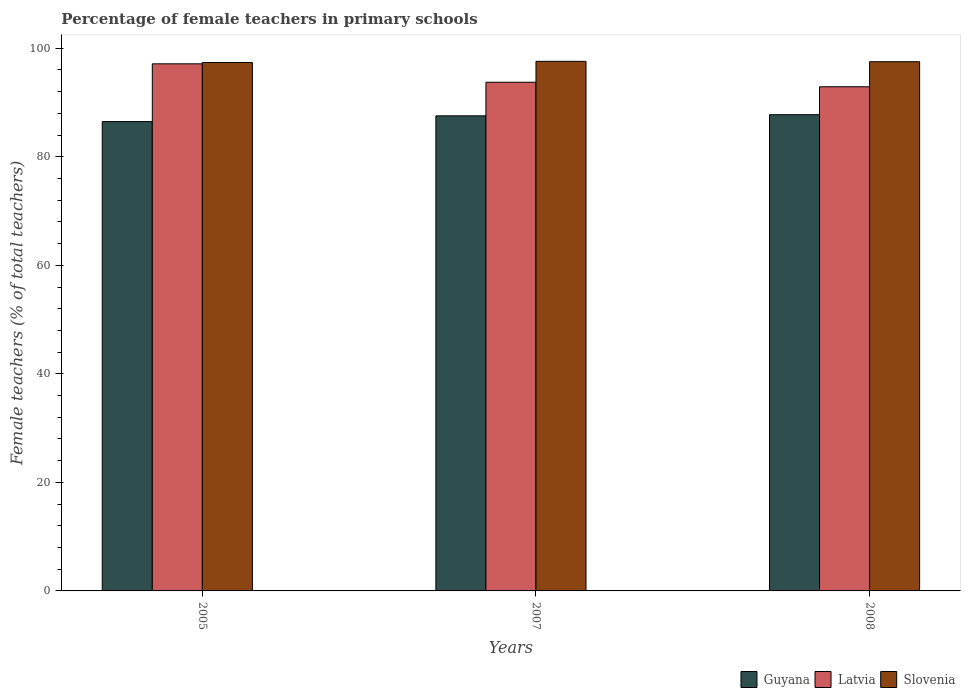How many different coloured bars are there?
Your response must be concise. 3. How many groups of bars are there?
Ensure brevity in your answer.  3. How many bars are there on the 1st tick from the left?
Make the answer very short. 3. How many bars are there on the 3rd tick from the right?
Your response must be concise. 3. What is the percentage of female teachers in Latvia in 2008?
Offer a terse response. 92.89. Across all years, what is the maximum percentage of female teachers in Slovenia?
Your answer should be compact. 97.58. Across all years, what is the minimum percentage of female teachers in Guyana?
Your answer should be compact. 86.48. In which year was the percentage of female teachers in Slovenia minimum?
Give a very brief answer. 2005. What is the total percentage of female teachers in Slovenia in the graph?
Your response must be concise. 292.46. What is the difference between the percentage of female teachers in Latvia in 2007 and that in 2008?
Make the answer very short. 0.84. What is the difference between the percentage of female teachers in Slovenia in 2008 and the percentage of female teachers in Latvia in 2005?
Provide a short and direct response. 0.39. What is the average percentage of female teachers in Guyana per year?
Ensure brevity in your answer.  87.26. In the year 2008, what is the difference between the percentage of female teachers in Latvia and percentage of female teachers in Slovenia?
Ensure brevity in your answer.  -4.62. In how many years, is the percentage of female teachers in Slovenia greater than 96 %?
Your answer should be compact. 3. What is the ratio of the percentage of female teachers in Slovenia in 2007 to that in 2008?
Keep it short and to the point. 1. Is the percentage of female teachers in Guyana in 2005 less than that in 2007?
Your answer should be very brief. Yes. What is the difference between the highest and the second highest percentage of female teachers in Latvia?
Give a very brief answer. 3.39. What is the difference between the highest and the lowest percentage of female teachers in Guyana?
Your answer should be very brief. 1.27. What does the 1st bar from the left in 2007 represents?
Provide a short and direct response. Guyana. What does the 2nd bar from the right in 2007 represents?
Provide a short and direct response. Latvia. Is it the case that in every year, the sum of the percentage of female teachers in Slovenia and percentage of female teachers in Guyana is greater than the percentage of female teachers in Latvia?
Offer a terse response. Yes. How many bars are there?
Your response must be concise. 9. Are all the bars in the graph horizontal?
Give a very brief answer. No. What is the difference between two consecutive major ticks on the Y-axis?
Keep it short and to the point. 20. What is the title of the graph?
Provide a short and direct response. Percentage of female teachers in primary schools. What is the label or title of the Y-axis?
Give a very brief answer. Female teachers (% of total teachers). What is the Female teachers (% of total teachers) of Guyana in 2005?
Make the answer very short. 86.48. What is the Female teachers (% of total teachers) in Latvia in 2005?
Offer a very short reply. 97.12. What is the Female teachers (% of total teachers) of Slovenia in 2005?
Your answer should be very brief. 97.37. What is the Female teachers (% of total teachers) in Guyana in 2007?
Keep it short and to the point. 87.54. What is the Female teachers (% of total teachers) in Latvia in 2007?
Your answer should be compact. 93.73. What is the Female teachers (% of total teachers) in Slovenia in 2007?
Offer a terse response. 97.58. What is the Female teachers (% of total teachers) in Guyana in 2008?
Give a very brief answer. 87.75. What is the Female teachers (% of total teachers) of Latvia in 2008?
Make the answer very short. 92.89. What is the Female teachers (% of total teachers) of Slovenia in 2008?
Provide a short and direct response. 97.51. Across all years, what is the maximum Female teachers (% of total teachers) in Guyana?
Give a very brief answer. 87.75. Across all years, what is the maximum Female teachers (% of total teachers) in Latvia?
Offer a very short reply. 97.12. Across all years, what is the maximum Female teachers (% of total teachers) of Slovenia?
Your answer should be very brief. 97.58. Across all years, what is the minimum Female teachers (% of total teachers) of Guyana?
Offer a very short reply. 86.48. Across all years, what is the minimum Female teachers (% of total teachers) in Latvia?
Your response must be concise. 92.89. Across all years, what is the minimum Female teachers (% of total teachers) in Slovenia?
Keep it short and to the point. 97.37. What is the total Female teachers (% of total teachers) of Guyana in the graph?
Offer a very short reply. 261.77. What is the total Female teachers (% of total teachers) in Latvia in the graph?
Provide a short and direct response. 283.75. What is the total Female teachers (% of total teachers) in Slovenia in the graph?
Ensure brevity in your answer.  292.46. What is the difference between the Female teachers (% of total teachers) in Guyana in 2005 and that in 2007?
Ensure brevity in your answer.  -1.06. What is the difference between the Female teachers (% of total teachers) in Latvia in 2005 and that in 2007?
Offer a terse response. 3.39. What is the difference between the Female teachers (% of total teachers) in Slovenia in 2005 and that in 2007?
Offer a terse response. -0.21. What is the difference between the Female teachers (% of total teachers) of Guyana in 2005 and that in 2008?
Your answer should be compact. -1.27. What is the difference between the Female teachers (% of total teachers) of Latvia in 2005 and that in 2008?
Your answer should be compact. 4.23. What is the difference between the Female teachers (% of total teachers) in Slovenia in 2005 and that in 2008?
Offer a terse response. -0.14. What is the difference between the Female teachers (% of total teachers) of Guyana in 2007 and that in 2008?
Make the answer very short. -0.21. What is the difference between the Female teachers (% of total teachers) of Latvia in 2007 and that in 2008?
Offer a very short reply. 0.84. What is the difference between the Female teachers (% of total teachers) of Slovenia in 2007 and that in 2008?
Your response must be concise. 0.07. What is the difference between the Female teachers (% of total teachers) in Guyana in 2005 and the Female teachers (% of total teachers) in Latvia in 2007?
Offer a terse response. -7.25. What is the difference between the Female teachers (% of total teachers) in Guyana in 2005 and the Female teachers (% of total teachers) in Slovenia in 2007?
Your answer should be very brief. -11.1. What is the difference between the Female teachers (% of total teachers) in Latvia in 2005 and the Female teachers (% of total teachers) in Slovenia in 2007?
Your response must be concise. -0.46. What is the difference between the Female teachers (% of total teachers) of Guyana in 2005 and the Female teachers (% of total teachers) of Latvia in 2008?
Provide a succinct answer. -6.42. What is the difference between the Female teachers (% of total teachers) in Guyana in 2005 and the Female teachers (% of total teachers) in Slovenia in 2008?
Your answer should be compact. -11.03. What is the difference between the Female teachers (% of total teachers) in Latvia in 2005 and the Female teachers (% of total teachers) in Slovenia in 2008?
Provide a succinct answer. -0.39. What is the difference between the Female teachers (% of total teachers) of Guyana in 2007 and the Female teachers (% of total teachers) of Latvia in 2008?
Keep it short and to the point. -5.36. What is the difference between the Female teachers (% of total teachers) of Guyana in 2007 and the Female teachers (% of total teachers) of Slovenia in 2008?
Make the answer very short. -9.97. What is the difference between the Female teachers (% of total teachers) in Latvia in 2007 and the Female teachers (% of total teachers) in Slovenia in 2008?
Provide a succinct answer. -3.78. What is the average Female teachers (% of total teachers) in Guyana per year?
Give a very brief answer. 87.26. What is the average Female teachers (% of total teachers) of Latvia per year?
Offer a very short reply. 94.58. What is the average Female teachers (% of total teachers) in Slovenia per year?
Provide a succinct answer. 97.49. In the year 2005, what is the difference between the Female teachers (% of total teachers) in Guyana and Female teachers (% of total teachers) in Latvia?
Keep it short and to the point. -10.64. In the year 2005, what is the difference between the Female teachers (% of total teachers) of Guyana and Female teachers (% of total teachers) of Slovenia?
Ensure brevity in your answer.  -10.89. In the year 2005, what is the difference between the Female teachers (% of total teachers) of Latvia and Female teachers (% of total teachers) of Slovenia?
Provide a succinct answer. -0.25. In the year 2007, what is the difference between the Female teachers (% of total teachers) in Guyana and Female teachers (% of total teachers) in Latvia?
Make the answer very short. -6.19. In the year 2007, what is the difference between the Female teachers (% of total teachers) of Guyana and Female teachers (% of total teachers) of Slovenia?
Provide a short and direct response. -10.04. In the year 2007, what is the difference between the Female teachers (% of total teachers) in Latvia and Female teachers (% of total teachers) in Slovenia?
Offer a terse response. -3.85. In the year 2008, what is the difference between the Female teachers (% of total teachers) of Guyana and Female teachers (% of total teachers) of Latvia?
Keep it short and to the point. -5.14. In the year 2008, what is the difference between the Female teachers (% of total teachers) of Guyana and Female teachers (% of total teachers) of Slovenia?
Your response must be concise. -9.76. In the year 2008, what is the difference between the Female teachers (% of total teachers) of Latvia and Female teachers (% of total teachers) of Slovenia?
Offer a terse response. -4.62. What is the ratio of the Female teachers (% of total teachers) of Guyana in 2005 to that in 2007?
Provide a succinct answer. 0.99. What is the ratio of the Female teachers (% of total teachers) of Latvia in 2005 to that in 2007?
Offer a terse response. 1.04. What is the ratio of the Female teachers (% of total teachers) in Guyana in 2005 to that in 2008?
Offer a terse response. 0.99. What is the ratio of the Female teachers (% of total teachers) in Latvia in 2005 to that in 2008?
Offer a terse response. 1.05. What is the ratio of the Female teachers (% of total teachers) in Slovenia in 2005 to that in 2008?
Ensure brevity in your answer.  1. What is the difference between the highest and the second highest Female teachers (% of total teachers) of Guyana?
Offer a very short reply. 0.21. What is the difference between the highest and the second highest Female teachers (% of total teachers) in Latvia?
Offer a very short reply. 3.39. What is the difference between the highest and the second highest Female teachers (% of total teachers) in Slovenia?
Make the answer very short. 0.07. What is the difference between the highest and the lowest Female teachers (% of total teachers) of Guyana?
Make the answer very short. 1.27. What is the difference between the highest and the lowest Female teachers (% of total teachers) of Latvia?
Keep it short and to the point. 4.23. What is the difference between the highest and the lowest Female teachers (% of total teachers) of Slovenia?
Offer a very short reply. 0.21. 